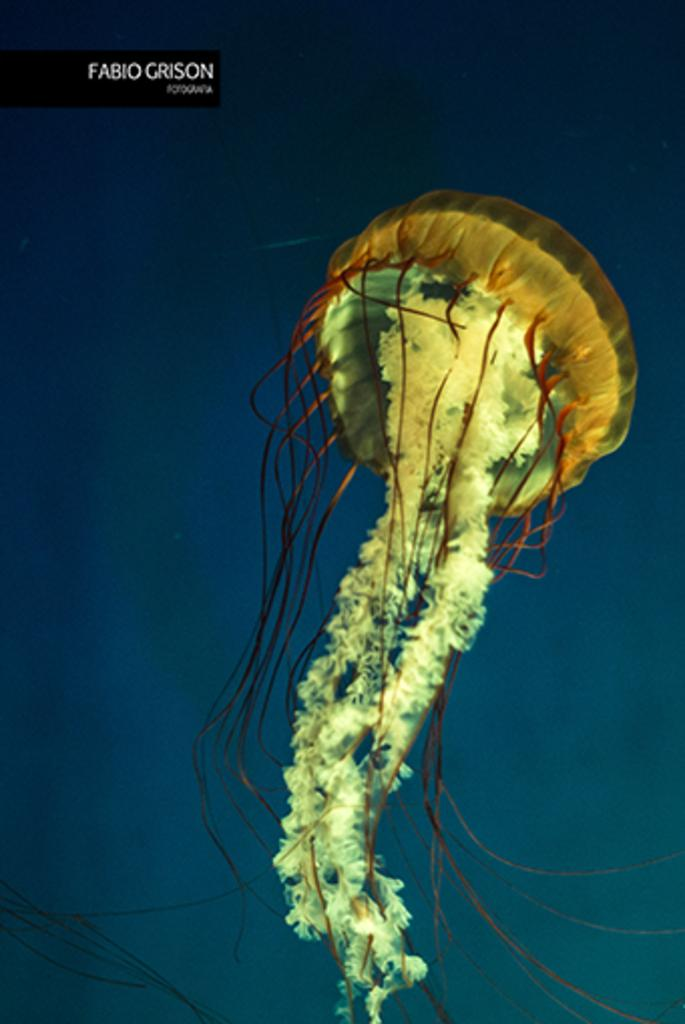What is the primary element visible in the image? There is water in the image. What type of creature can be seen in the water? There is a jellyfish in the water. How does the giraffe spark a conversation with the jellyfish in the image? There is no giraffe present in the image, so it cannot spark a conversation with the jellyfish. 